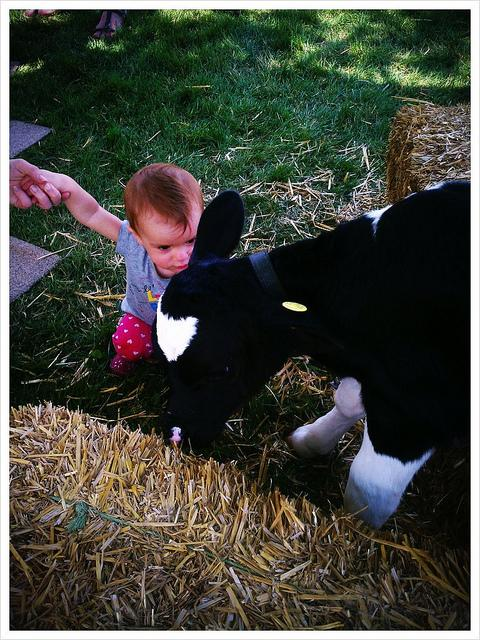What kind of food eater is the animal? herbivore 